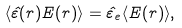<formula> <loc_0><loc_0><loc_500><loc_500>\langle \hat { \varepsilon } ( r ) { E } ( r ) \rangle = \hat { \varepsilon } _ { e } \langle { E } ( r ) \rangle ,</formula> 